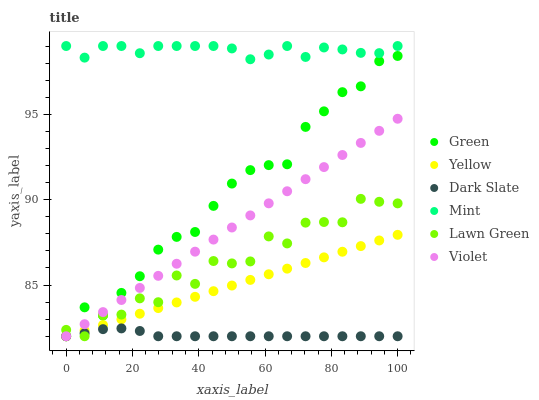Does Dark Slate have the minimum area under the curve?
Answer yes or no. Yes. Does Mint have the maximum area under the curve?
Answer yes or no. Yes. Does Yellow have the minimum area under the curve?
Answer yes or no. No. Does Yellow have the maximum area under the curve?
Answer yes or no. No. Is Violet the smoothest?
Answer yes or no. Yes. Is Lawn Green the roughest?
Answer yes or no. Yes. Is Yellow the smoothest?
Answer yes or no. No. Is Yellow the roughest?
Answer yes or no. No. Does Lawn Green have the lowest value?
Answer yes or no. Yes. Does Mint have the lowest value?
Answer yes or no. No. Does Mint have the highest value?
Answer yes or no. Yes. Does Yellow have the highest value?
Answer yes or no. No. Is Yellow less than Mint?
Answer yes or no. Yes. Is Mint greater than Violet?
Answer yes or no. Yes. Does Dark Slate intersect Yellow?
Answer yes or no. Yes. Is Dark Slate less than Yellow?
Answer yes or no. No. Is Dark Slate greater than Yellow?
Answer yes or no. No. Does Yellow intersect Mint?
Answer yes or no. No. 